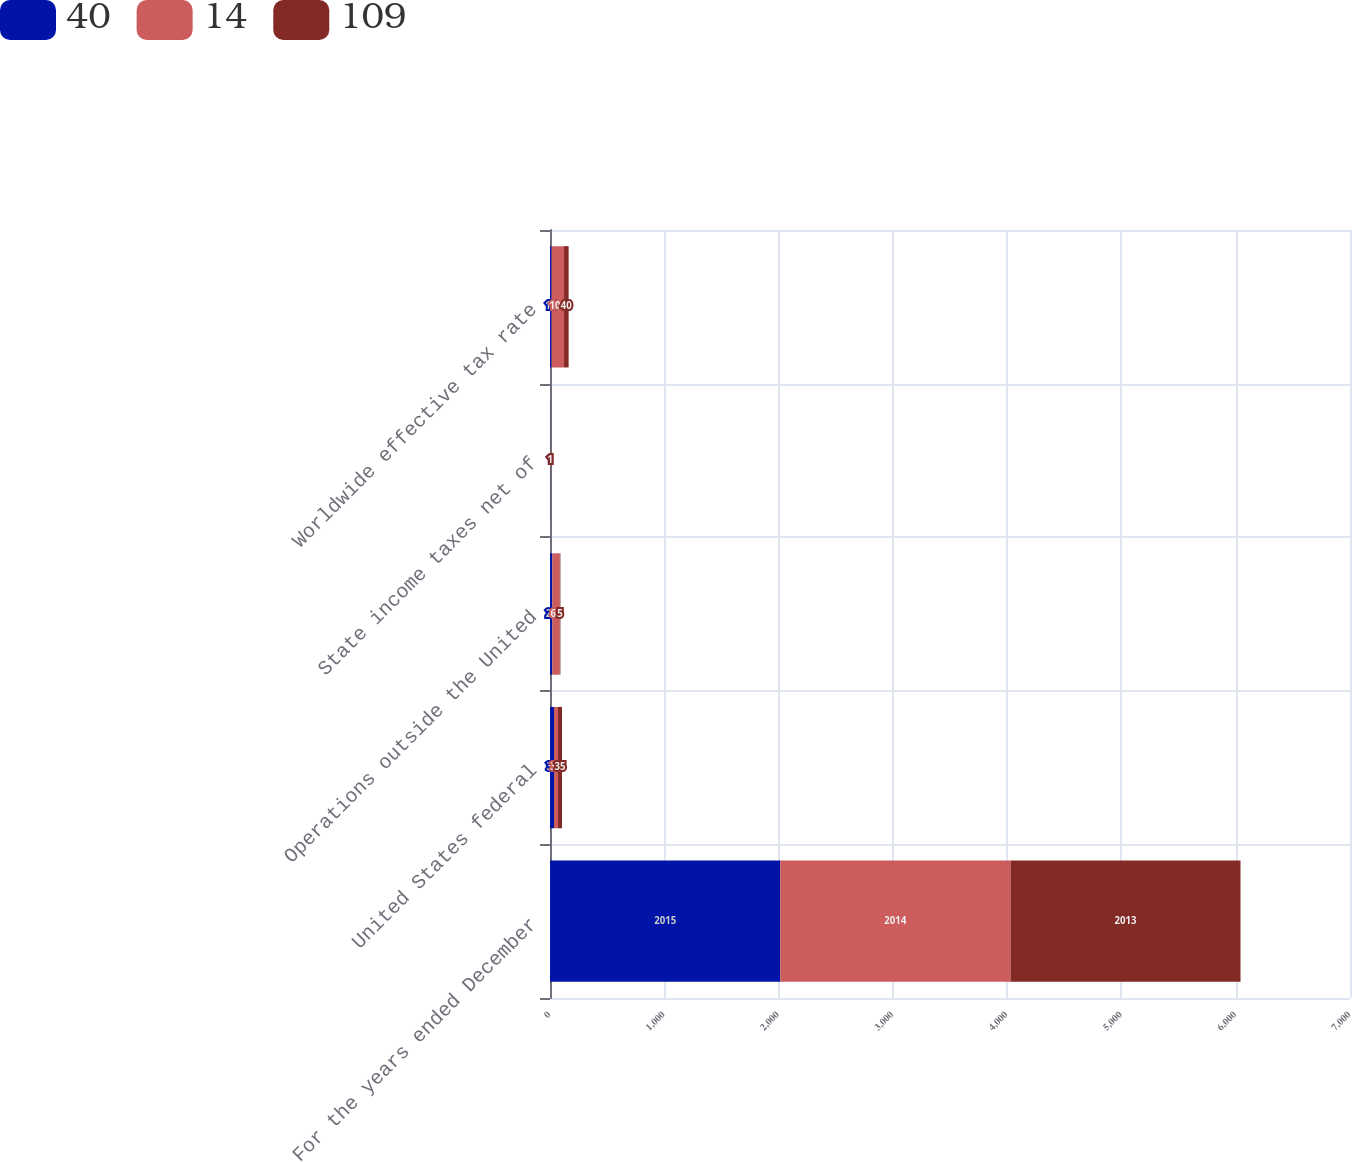<chart> <loc_0><loc_0><loc_500><loc_500><stacked_bar_chart><ecel><fcel>For the years ended December<fcel>United States federal<fcel>Operations outside the United<fcel>State income taxes net of<fcel>Worldwide effective tax rate<nl><fcel>40<fcel>2015<fcel>35<fcel>21<fcel>1<fcel>14<nl><fcel>14<fcel>2014<fcel>35<fcel>65<fcel>1<fcel>109<nl><fcel>109<fcel>2013<fcel>35<fcel>5<fcel>1<fcel>40<nl></chart> 